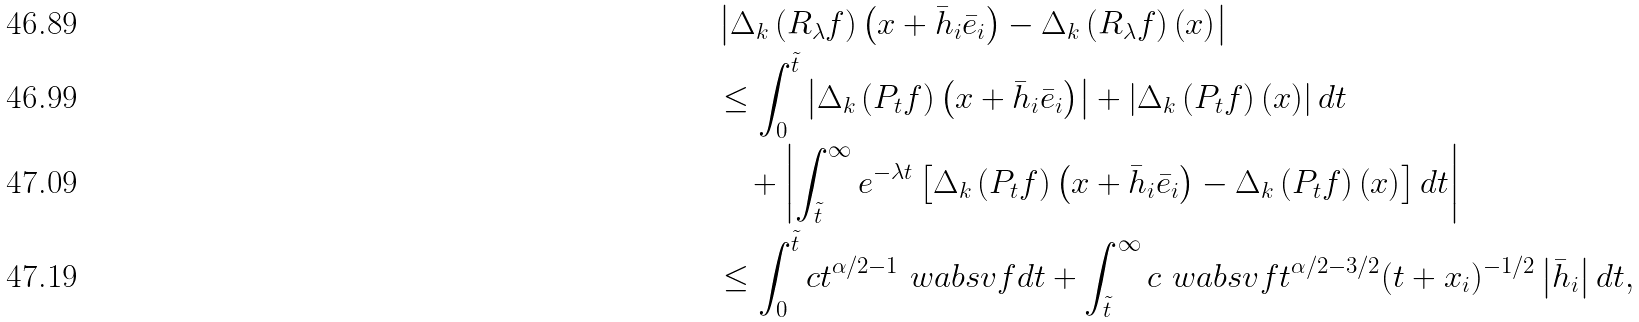<formula> <loc_0><loc_0><loc_500><loc_500>& \left | \Delta _ { k } \left ( R _ { \lambda } f \right ) \left ( x + \bar { h } _ { i } \bar { e } _ { i } \right ) - \Delta _ { k } \left ( R _ { \lambda } f \right ) \left ( x \right ) \right | \\ & \leq \int _ { 0 } ^ { \tilde { t } } \left | \Delta _ { k } \left ( P _ { t } f \right ) \left ( x + \bar { h } _ { i } \bar { e } _ { i } \right ) \right | + \left | \Delta _ { k } \left ( P _ { t } f \right ) \left ( x \right ) \right | d t \\ & \quad + \left | \int _ { \tilde { t } } ^ { \infty } e ^ { - \lambda t } \left [ \Delta _ { k } \left ( P _ { t } f \right ) \left ( x + \bar { h } _ { i } \bar { e } _ { i } \right ) - \Delta _ { k } \left ( P _ { t } f \right ) \left ( x \right ) \right ] d t \right | \\ & \leq \int _ { 0 } ^ { \tilde { t } } c t ^ { \alpha / 2 - 1 } \ w a b s v { f } d t + \int _ { \tilde { t } } ^ { \infty } c \ w a b s v { f } t ^ { \alpha / 2 - 3 / 2 } ( t + x _ { i } ) ^ { - 1 / 2 } \left | \bar { h } _ { i } \right | d t ,</formula> 